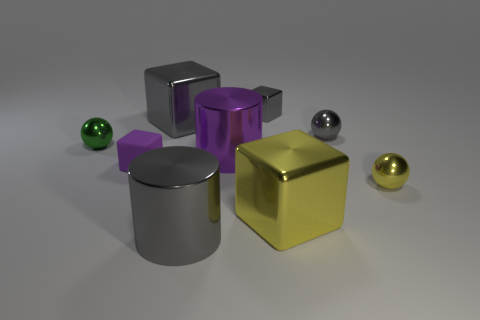What is the texture of the objects like, and does it tell us anything about how they feel to touch? The objects have a smooth and reflective texture, suggesting they would feel sleek and cool to the touch. This commonly indicates materials such as metal or polished plastic. Given their sizes and shapes, where might these objects be typically found? Given their geometric shapes and uniform colors, these objects could be part of an educational tool for teaching shapes or as decorative elements in a modern, minimalist setting. 